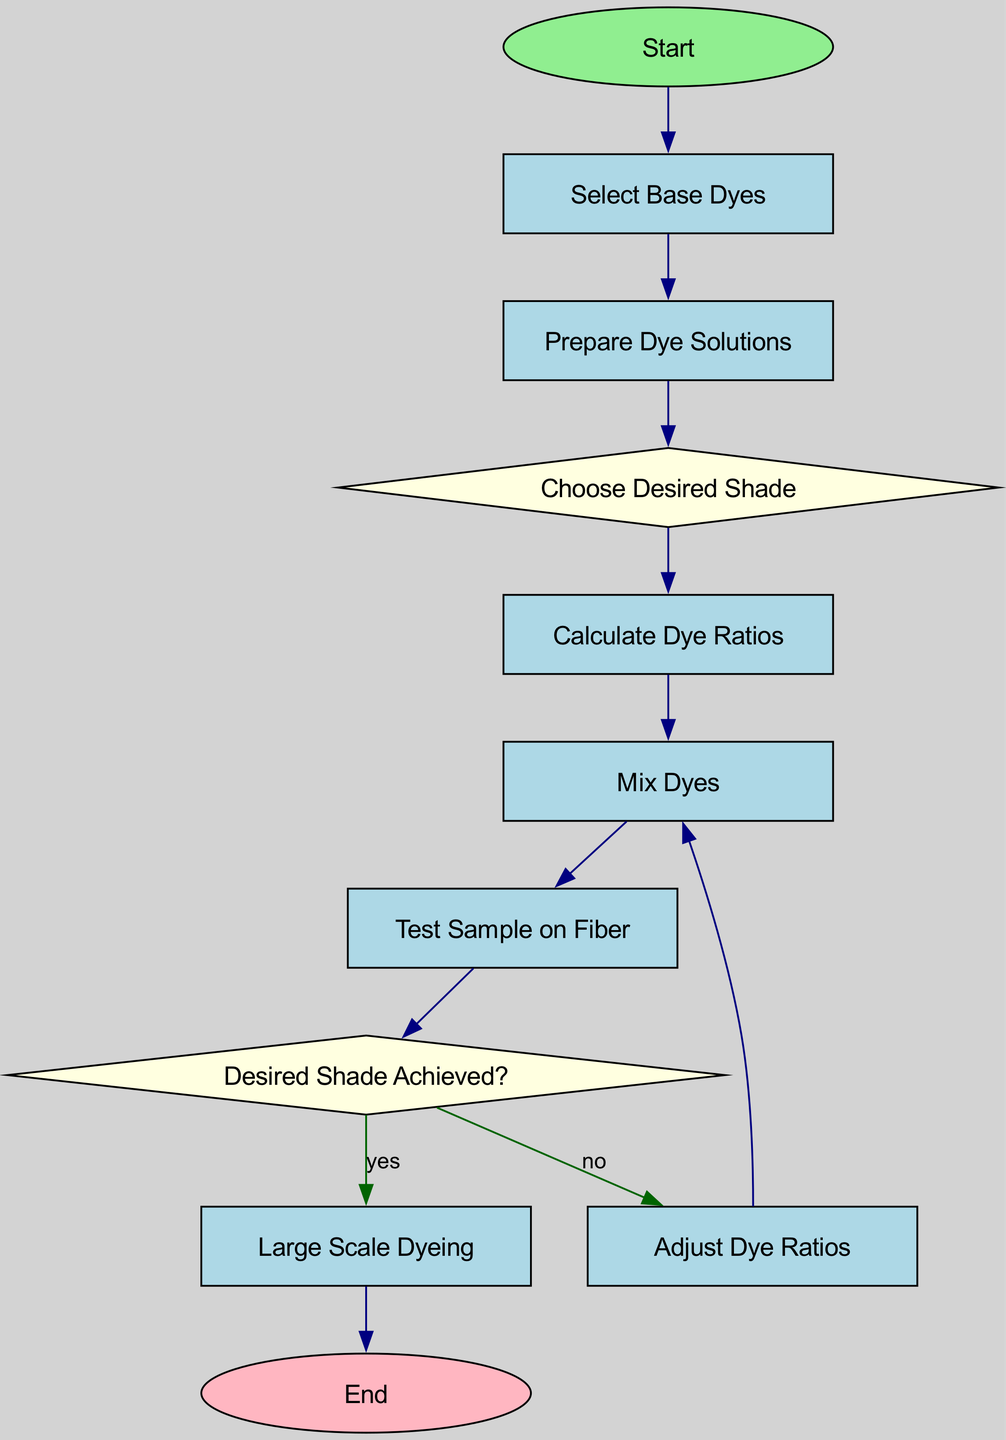What is the first step in the diagram? The first step in the diagram is labeled "Start," indicating the beginning of the dye mixing process.
Answer: Start How many processes are there in the diagram? The processes include selecting base dyes, preparing dye solutions, calculating dye ratios, mixing dyes, testing samples on fiber, adjusting dye ratios, and large scale dyeing. This totals to seven process nodes.
Answer: Seven What is the condition to proceed to large scale dyeing? The condition to proceed to large scale dyeing is that the desired shade has been achieved, as indicated by the decision node.
Answer: Yes After mixing dyes, what is the next step? After mixing dyes, the next step is to test a sample on fiber, as per the flow in the diagram.
Answer: Test Sample on Fiber What happens if the desired shade is not achieved? If the desired shade is not achieved, the flowchart directs to a step where dye ratios are adjusted, allowing for refinement of the dye mixture.
Answer: Adjust Dye Ratios Which nodes represent decisions in the flowchart? The nodes that represent decisions are "Choose Desired Shade" and "Desired Shade Achieved?" These nodes indicate points where a choice must be made before proceeding.
Answer: Choose Desired Shade, Desired Shade Achieved? What step follows the preparation of dye solutions? The step that follows the preparation of dye solutions is choosing the desired shade, indicating the next phase in the dyeing process.
Answer: Choose Desired Shade How many connections are shown in the flowchart? The flowchart shows a total of ten connections, linking all the steps and decisions together in the dye mixing process.
Answer: Ten What color is used for process nodes in the diagram? The color used for process nodes in the diagram is light blue, identifying each of those steps visually within the flowchart.
Answer: Light Blue 